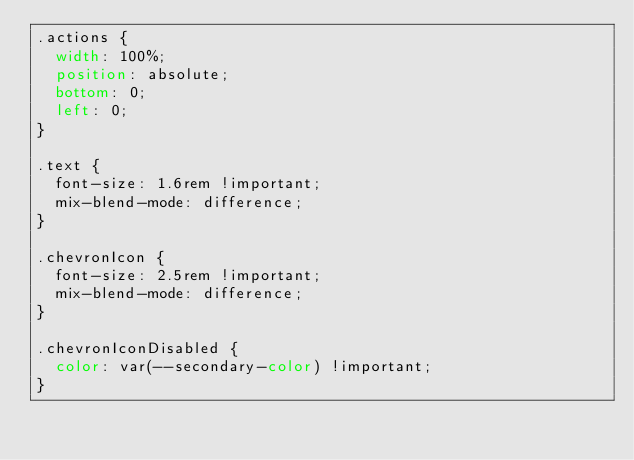Convert code to text. <code><loc_0><loc_0><loc_500><loc_500><_CSS_>.actions {
  width: 100%;
  position: absolute;
  bottom: 0;
  left: 0;
}

.text {
  font-size: 1.6rem !important;
  mix-blend-mode: difference;
}

.chevronIcon {
  font-size: 2.5rem !important;
  mix-blend-mode: difference;
}

.chevronIconDisabled {
  color: var(--secondary-color) !important;
}
</code> 